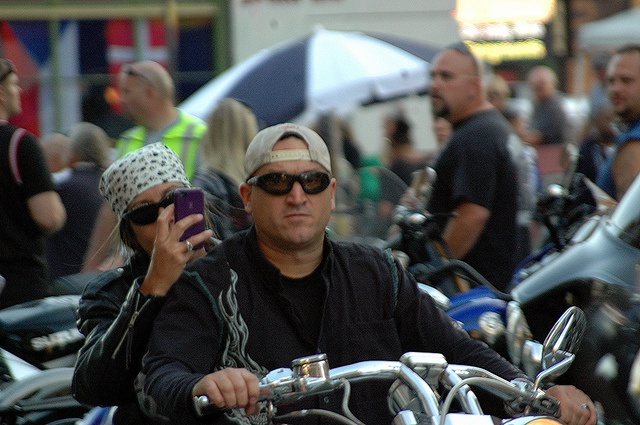Describe the objects in this image and their specific colors. I can see people in black, gray, and maroon tones, people in black, gray, darkgray, and maroon tones, motorcycle in black, gray, white, and darkgray tones, people in black, gray, and maroon tones, and motorcycle in black, gray, and darkgray tones in this image. 